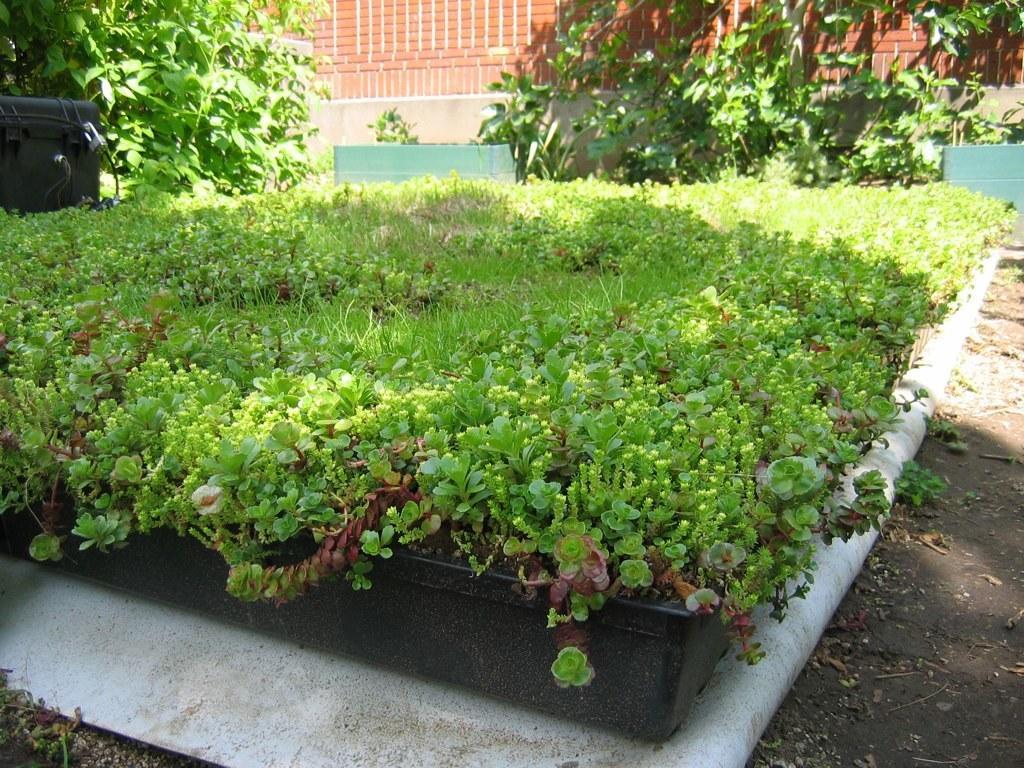Describe this image in one or two sentences. In this image we can see a group of plants in a container. On the backside we can see a box, some plants and a wall. 